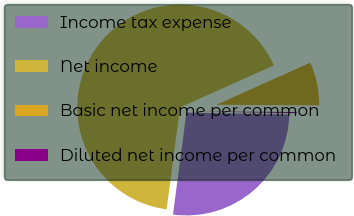Convert chart. <chart><loc_0><loc_0><loc_500><loc_500><pie_chart><fcel>Income tax expense<fcel>Net income<fcel>Basic net income per common<fcel>Diluted net income per common<nl><fcel>26.8%<fcel>66.21%<fcel>6.79%<fcel>0.19%<nl></chart> 